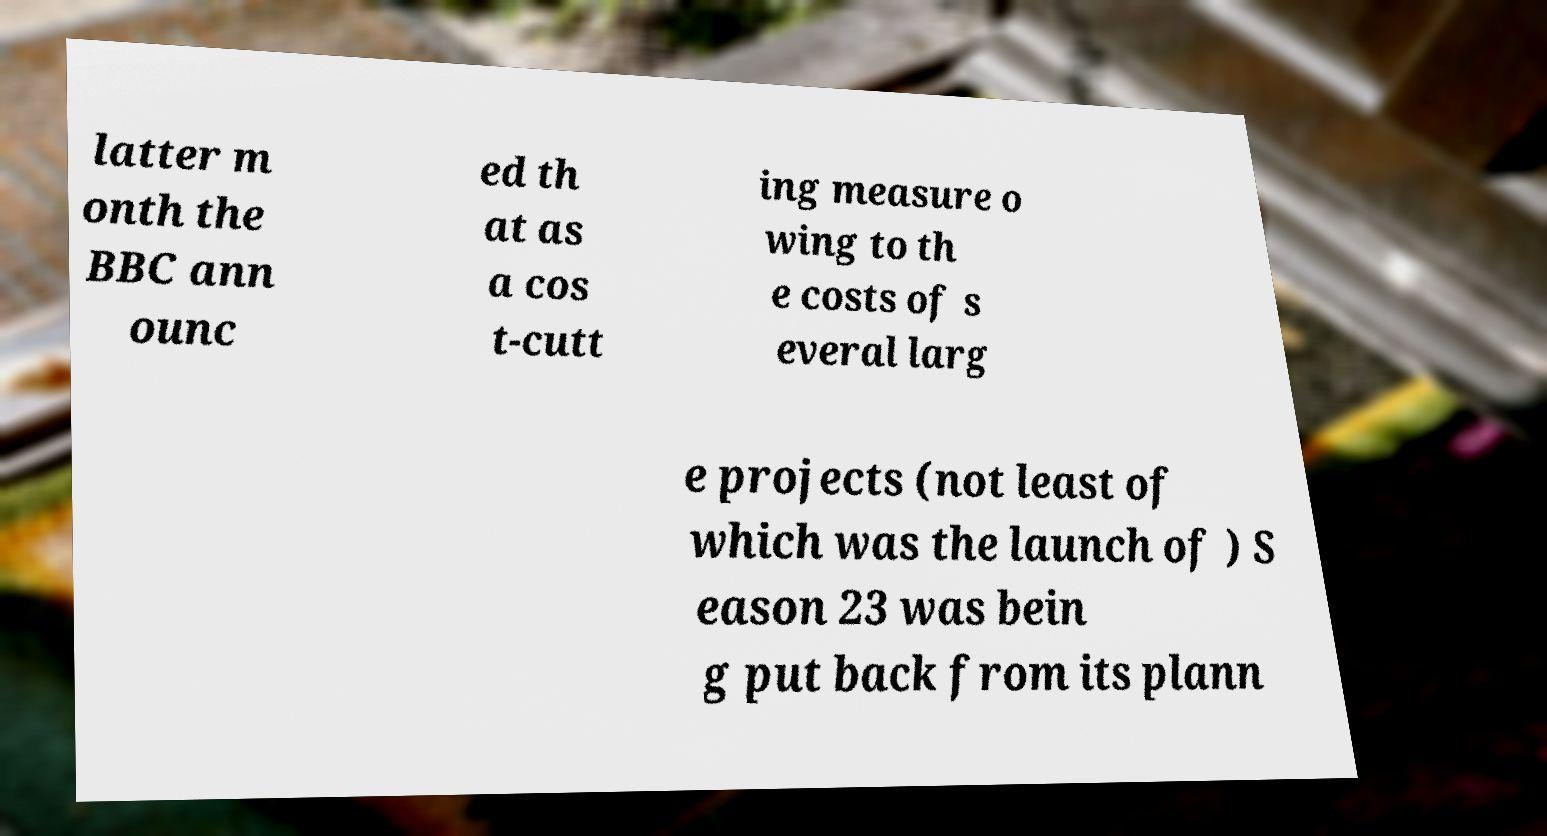I need the written content from this picture converted into text. Can you do that? latter m onth the BBC ann ounc ed th at as a cos t-cutt ing measure o wing to th e costs of s everal larg e projects (not least of which was the launch of ) S eason 23 was bein g put back from its plann 